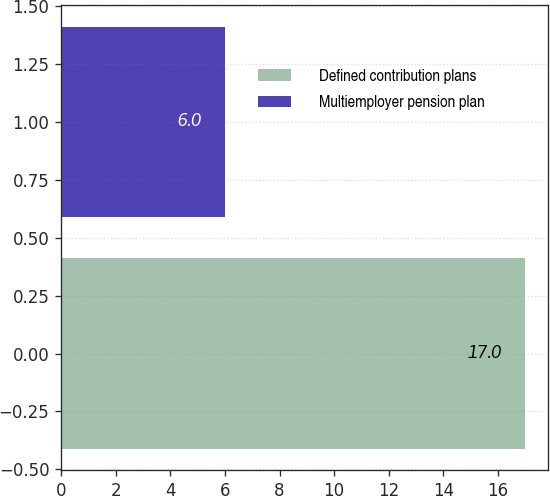Convert chart to OTSL. <chart><loc_0><loc_0><loc_500><loc_500><bar_chart><fcel>Defined contribution plans<fcel>Multiemployer pension plan<nl><fcel>17<fcel>6<nl></chart> 